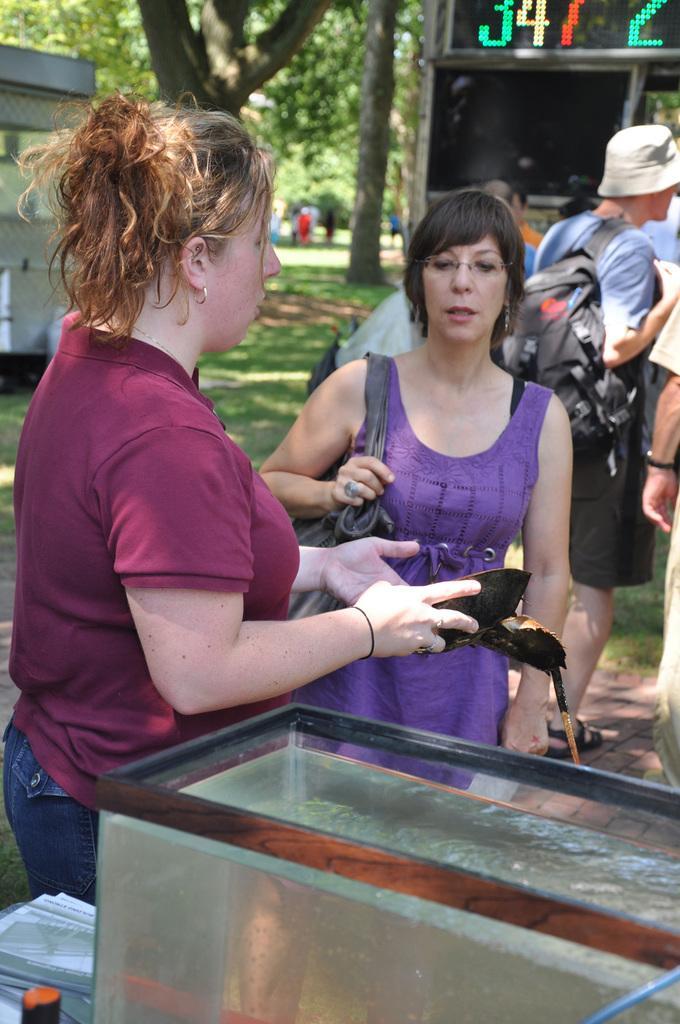How would you summarize this image in a sentence or two? In the image there is a woman standing beside a water tank and she is holding some item in her hand there are some other people standing in front of her and there is a stall in the background, around that stall there are trees. 